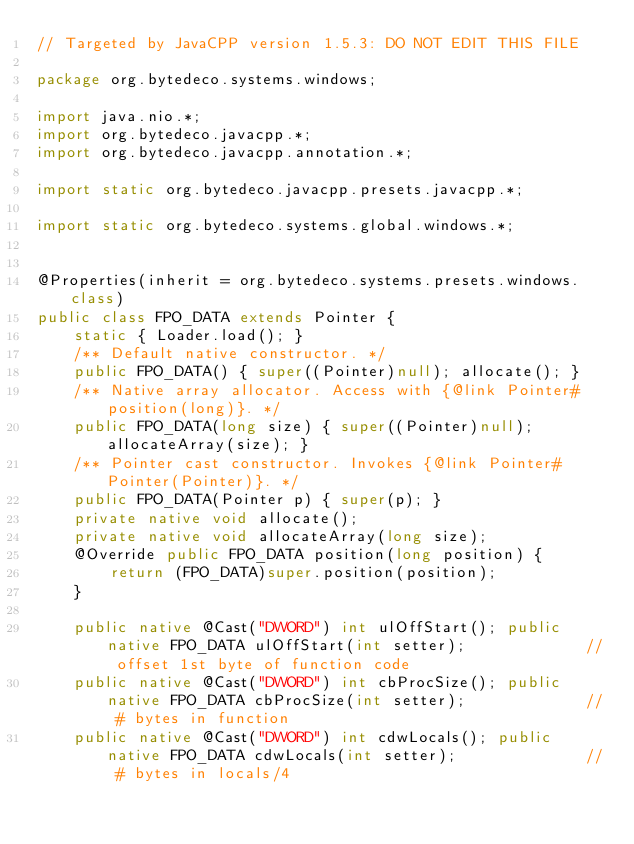<code> <loc_0><loc_0><loc_500><loc_500><_Java_>// Targeted by JavaCPP version 1.5.3: DO NOT EDIT THIS FILE

package org.bytedeco.systems.windows;

import java.nio.*;
import org.bytedeco.javacpp.*;
import org.bytedeco.javacpp.annotation.*;

import static org.bytedeco.javacpp.presets.javacpp.*;

import static org.bytedeco.systems.global.windows.*;


@Properties(inherit = org.bytedeco.systems.presets.windows.class)
public class FPO_DATA extends Pointer {
    static { Loader.load(); }
    /** Default native constructor. */
    public FPO_DATA() { super((Pointer)null); allocate(); }
    /** Native array allocator. Access with {@link Pointer#position(long)}. */
    public FPO_DATA(long size) { super((Pointer)null); allocateArray(size); }
    /** Pointer cast constructor. Invokes {@link Pointer#Pointer(Pointer)}. */
    public FPO_DATA(Pointer p) { super(p); }
    private native void allocate();
    private native void allocateArray(long size);
    @Override public FPO_DATA position(long position) {
        return (FPO_DATA)super.position(position);
    }

    public native @Cast("DWORD") int ulOffStart(); public native FPO_DATA ulOffStart(int setter);             // offset 1st byte of function code
    public native @Cast("DWORD") int cbProcSize(); public native FPO_DATA cbProcSize(int setter);             // # bytes in function
    public native @Cast("DWORD") int cdwLocals(); public native FPO_DATA cdwLocals(int setter);              // # bytes in locals/4</code> 